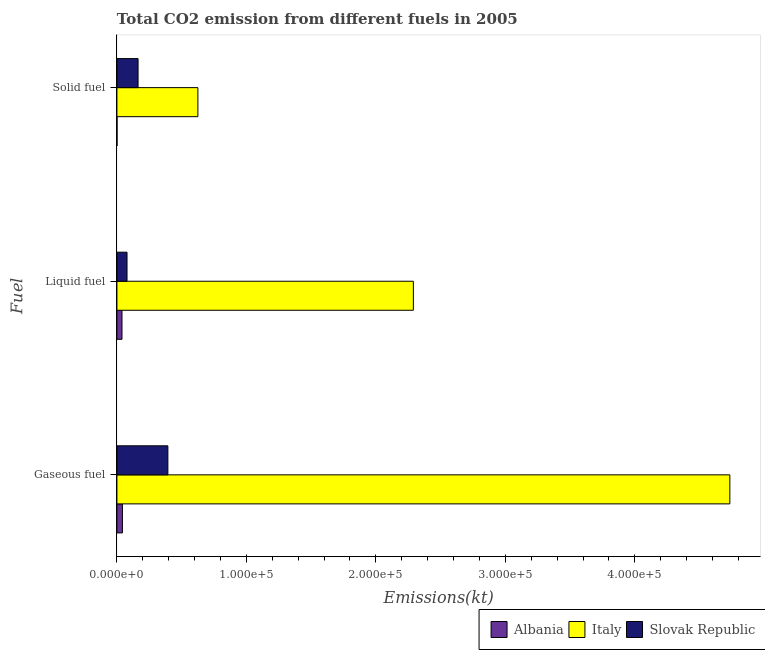Are the number of bars per tick equal to the number of legend labels?
Your answer should be compact. Yes. Are the number of bars on each tick of the Y-axis equal?
Give a very brief answer. Yes. How many bars are there on the 3rd tick from the top?
Give a very brief answer. 3. How many bars are there on the 3rd tick from the bottom?
Your response must be concise. 3. What is the label of the 3rd group of bars from the top?
Offer a terse response. Gaseous fuel. What is the amount of co2 emissions from gaseous fuel in Italy?
Provide a short and direct response. 4.73e+05. Across all countries, what is the maximum amount of co2 emissions from solid fuel?
Give a very brief answer. 6.25e+04. Across all countries, what is the minimum amount of co2 emissions from solid fuel?
Ensure brevity in your answer.  73.34. In which country was the amount of co2 emissions from solid fuel maximum?
Offer a very short reply. Italy. In which country was the amount of co2 emissions from gaseous fuel minimum?
Keep it short and to the point. Albania. What is the total amount of co2 emissions from solid fuel in the graph?
Provide a succinct answer. 7.89e+04. What is the difference between the amount of co2 emissions from gaseous fuel in Albania and that in Slovak Republic?
Make the answer very short. -3.51e+04. What is the difference between the amount of co2 emissions from liquid fuel in Slovak Republic and the amount of co2 emissions from gaseous fuel in Italy?
Make the answer very short. -4.66e+05. What is the average amount of co2 emissions from gaseous fuel per country?
Provide a succinct answer. 1.72e+05. What is the difference between the amount of co2 emissions from liquid fuel and amount of co2 emissions from gaseous fuel in Albania?
Your answer should be compact. -337.36. What is the ratio of the amount of co2 emissions from gaseous fuel in Italy to that in Slovak Republic?
Keep it short and to the point. 12.03. Is the amount of co2 emissions from solid fuel in Slovak Republic less than that in Italy?
Provide a succinct answer. Yes. Is the difference between the amount of co2 emissions from gaseous fuel in Slovak Republic and Albania greater than the difference between the amount of co2 emissions from liquid fuel in Slovak Republic and Albania?
Provide a succinct answer. Yes. What is the difference between the highest and the second highest amount of co2 emissions from solid fuel?
Your response must be concise. 4.62e+04. What is the difference between the highest and the lowest amount of co2 emissions from solid fuel?
Offer a very short reply. 6.25e+04. Is the sum of the amount of co2 emissions from gaseous fuel in Albania and Italy greater than the maximum amount of co2 emissions from solid fuel across all countries?
Ensure brevity in your answer.  Yes. What does the 1st bar from the top in Liquid fuel represents?
Ensure brevity in your answer.  Slovak Republic. What does the 2nd bar from the bottom in Liquid fuel represents?
Offer a terse response. Italy. Are all the bars in the graph horizontal?
Provide a succinct answer. Yes. Are the values on the major ticks of X-axis written in scientific E-notation?
Give a very brief answer. Yes. Does the graph contain any zero values?
Your response must be concise. No. Where does the legend appear in the graph?
Give a very brief answer. Bottom right. How many legend labels are there?
Your answer should be very brief. 3. How are the legend labels stacked?
Your answer should be very brief. Horizontal. What is the title of the graph?
Your response must be concise. Total CO2 emission from different fuels in 2005. What is the label or title of the X-axis?
Ensure brevity in your answer.  Emissions(kt). What is the label or title of the Y-axis?
Offer a terse response. Fuel. What is the Emissions(kt) in Albania in Gaseous fuel?
Ensure brevity in your answer.  4253.72. What is the Emissions(kt) of Italy in Gaseous fuel?
Offer a very short reply. 4.73e+05. What is the Emissions(kt) of Slovak Republic in Gaseous fuel?
Ensure brevity in your answer.  3.94e+04. What is the Emissions(kt) in Albania in Liquid fuel?
Offer a terse response. 3916.36. What is the Emissions(kt) in Italy in Liquid fuel?
Your response must be concise. 2.29e+05. What is the Emissions(kt) in Slovak Republic in Liquid fuel?
Ensure brevity in your answer.  7799.71. What is the Emissions(kt) in Albania in Solid fuel?
Your response must be concise. 73.34. What is the Emissions(kt) in Italy in Solid fuel?
Your answer should be very brief. 6.25e+04. What is the Emissions(kt) of Slovak Republic in Solid fuel?
Your answer should be compact. 1.63e+04. Across all Fuel, what is the maximum Emissions(kt) in Albania?
Keep it short and to the point. 4253.72. Across all Fuel, what is the maximum Emissions(kt) in Italy?
Provide a short and direct response. 4.73e+05. Across all Fuel, what is the maximum Emissions(kt) in Slovak Republic?
Your answer should be compact. 3.94e+04. Across all Fuel, what is the minimum Emissions(kt) in Albania?
Your answer should be compact. 73.34. Across all Fuel, what is the minimum Emissions(kt) of Italy?
Your answer should be very brief. 6.25e+04. Across all Fuel, what is the minimum Emissions(kt) in Slovak Republic?
Offer a terse response. 7799.71. What is the total Emissions(kt) in Albania in the graph?
Provide a short and direct response. 8243.42. What is the total Emissions(kt) in Italy in the graph?
Give a very brief answer. 7.65e+05. What is the total Emissions(kt) of Slovak Republic in the graph?
Offer a very short reply. 6.35e+04. What is the difference between the Emissions(kt) of Albania in Gaseous fuel and that in Liquid fuel?
Your response must be concise. 337.36. What is the difference between the Emissions(kt) in Italy in Gaseous fuel and that in Liquid fuel?
Provide a short and direct response. 2.44e+05. What is the difference between the Emissions(kt) of Slovak Republic in Gaseous fuel and that in Liquid fuel?
Give a very brief answer. 3.16e+04. What is the difference between the Emissions(kt) of Albania in Gaseous fuel and that in Solid fuel?
Ensure brevity in your answer.  4180.38. What is the difference between the Emissions(kt) of Italy in Gaseous fuel and that in Solid fuel?
Your response must be concise. 4.11e+05. What is the difference between the Emissions(kt) in Slovak Republic in Gaseous fuel and that in Solid fuel?
Keep it short and to the point. 2.30e+04. What is the difference between the Emissions(kt) in Albania in Liquid fuel and that in Solid fuel?
Give a very brief answer. 3843.02. What is the difference between the Emissions(kt) in Italy in Liquid fuel and that in Solid fuel?
Offer a very short reply. 1.66e+05. What is the difference between the Emissions(kt) of Slovak Republic in Liquid fuel and that in Solid fuel?
Keep it short and to the point. -8533.11. What is the difference between the Emissions(kt) of Albania in Gaseous fuel and the Emissions(kt) of Italy in Liquid fuel?
Your answer should be compact. -2.25e+05. What is the difference between the Emissions(kt) of Albania in Gaseous fuel and the Emissions(kt) of Slovak Republic in Liquid fuel?
Your answer should be compact. -3545.99. What is the difference between the Emissions(kt) of Italy in Gaseous fuel and the Emissions(kt) of Slovak Republic in Liquid fuel?
Your response must be concise. 4.66e+05. What is the difference between the Emissions(kt) of Albania in Gaseous fuel and the Emissions(kt) of Italy in Solid fuel?
Your answer should be very brief. -5.83e+04. What is the difference between the Emissions(kt) in Albania in Gaseous fuel and the Emissions(kt) in Slovak Republic in Solid fuel?
Offer a very short reply. -1.21e+04. What is the difference between the Emissions(kt) of Italy in Gaseous fuel and the Emissions(kt) of Slovak Republic in Solid fuel?
Your answer should be very brief. 4.57e+05. What is the difference between the Emissions(kt) in Albania in Liquid fuel and the Emissions(kt) in Italy in Solid fuel?
Keep it short and to the point. -5.86e+04. What is the difference between the Emissions(kt) in Albania in Liquid fuel and the Emissions(kt) in Slovak Republic in Solid fuel?
Provide a short and direct response. -1.24e+04. What is the difference between the Emissions(kt) in Italy in Liquid fuel and the Emissions(kt) in Slovak Republic in Solid fuel?
Offer a very short reply. 2.13e+05. What is the average Emissions(kt) of Albania per Fuel?
Offer a very short reply. 2747.81. What is the average Emissions(kt) in Italy per Fuel?
Your answer should be compact. 2.55e+05. What is the average Emissions(kt) of Slovak Republic per Fuel?
Offer a very short reply. 2.12e+04. What is the difference between the Emissions(kt) of Albania and Emissions(kt) of Italy in Gaseous fuel?
Offer a terse response. -4.69e+05. What is the difference between the Emissions(kt) in Albania and Emissions(kt) in Slovak Republic in Gaseous fuel?
Offer a terse response. -3.51e+04. What is the difference between the Emissions(kt) of Italy and Emissions(kt) of Slovak Republic in Gaseous fuel?
Offer a terse response. 4.34e+05. What is the difference between the Emissions(kt) in Albania and Emissions(kt) in Italy in Liquid fuel?
Give a very brief answer. -2.25e+05. What is the difference between the Emissions(kt) of Albania and Emissions(kt) of Slovak Republic in Liquid fuel?
Ensure brevity in your answer.  -3883.35. What is the difference between the Emissions(kt) of Italy and Emissions(kt) of Slovak Republic in Liquid fuel?
Ensure brevity in your answer.  2.21e+05. What is the difference between the Emissions(kt) in Albania and Emissions(kt) in Italy in Solid fuel?
Make the answer very short. -6.25e+04. What is the difference between the Emissions(kt) in Albania and Emissions(kt) in Slovak Republic in Solid fuel?
Your response must be concise. -1.63e+04. What is the difference between the Emissions(kt) in Italy and Emissions(kt) in Slovak Republic in Solid fuel?
Provide a succinct answer. 4.62e+04. What is the ratio of the Emissions(kt) of Albania in Gaseous fuel to that in Liquid fuel?
Give a very brief answer. 1.09. What is the ratio of the Emissions(kt) of Italy in Gaseous fuel to that in Liquid fuel?
Give a very brief answer. 2.07. What is the ratio of the Emissions(kt) of Slovak Republic in Gaseous fuel to that in Liquid fuel?
Your response must be concise. 5.05. What is the ratio of the Emissions(kt) in Albania in Gaseous fuel to that in Solid fuel?
Provide a succinct answer. 58. What is the ratio of the Emissions(kt) in Italy in Gaseous fuel to that in Solid fuel?
Keep it short and to the point. 7.57. What is the ratio of the Emissions(kt) in Slovak Republic in Gaseous fuel to that in Solid fuel?
Make the answer very short. 2.41. What is the ratio of the Emissions(kt) of Albania in Liquid fuel to that in Solid fuel?
Offer a very short reply. 53.4. What is the ratio of the Emissions(kt) in Italy in Liquid fuel to that in Solid fuel?
Your answer should be compact. 3.66. What is the ratio of the Emissions(kt) of Slovak Republic in Liquid fuel to that in Solid fuel?
Give a very brief answer. 0.48. What is the difference between the highest and the second highest Emissions(kt) of Albania?
Keep it short and to the point. 337.36. What is the difference between the highest and the second highest Emissions(kt) of Italy?
Offer a very short reply. 2.44e+05. What is the difference between the highest and the second highest Emissions(kt) of Slovak Republic?
Provide a succinct answer. 2.30e+04. What is the difference between the highest and the lowest Emissions(kt) of Albania?
Offer a terse response. 4180.38. What is the difference between the highest and the lowest Emissions(kt) of Italy?
Provide a short and direct response. 4.11e+05. What is the difference between the highest and the lowest Emissions(kt) in Slovak Republic?
Your answer should be very brief. 3.16e+04. 